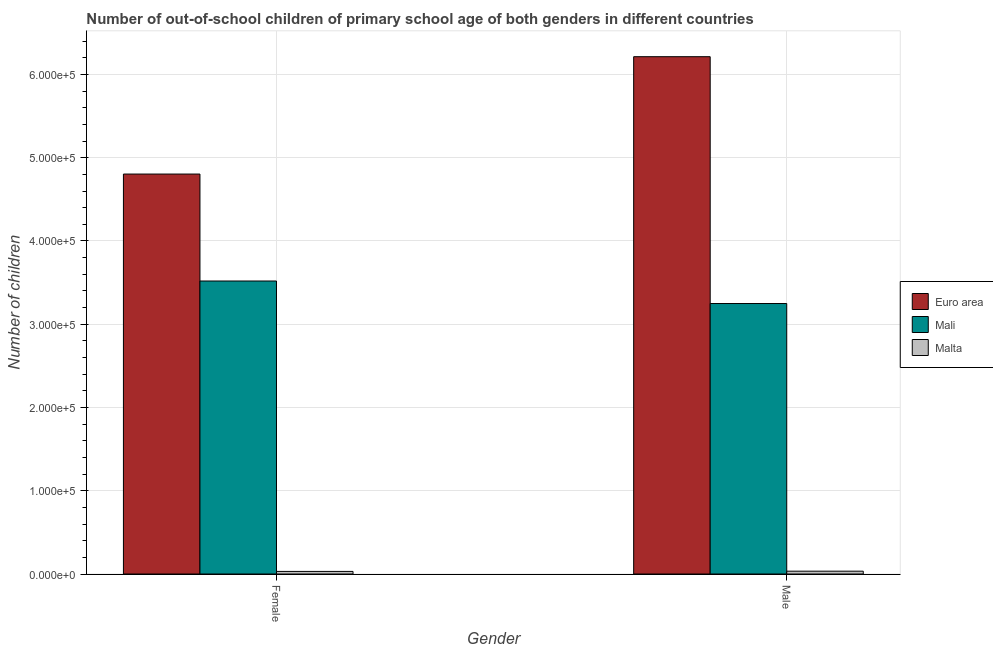Are the number of bars on each tick of the X-axis equal?
Provide a succinct answer. Yes. How many bars are there on the 1st tick from the right?
Provide a succinct answer. 3. What is the number of female out-of-school students in Malta?
Offer a terse response. 3105. Across all countries, what is the maximum number of female out-of-school students?
Make the answer very short. 4.80e+05. Across all countries, what is the minimum number of male out-of-school students?
Provide a succinct answer. 3394. In which country was the number of female out-of-school students maximum?
Offer a very short reply. Euro area. In which country was the number of female out-of-school students minimum?
Offer a terse response. Malta. What is the total number of female out-of-school students in the graph?
Ensure brevity in your answer.  8.35e+05. What is the difference between the number of male out-of-school students in Malta and that in Euro area?
Offer a terse response. -6.18e+05. What is the difference between the number of female out-of-school students in Mali and the number of male out-of-school students in Malta?
Your answer should be very brief. 3.49e+05. What is the average number of female out-of-school students per country?
Give a very brief answer. 2.78e+05. What is the difference between the number of male out-of-school students and number of female out-of-school students in Malta?
Provide a short and direct response. 289. What is the ratio of the number of female out-of-school students in Euro area to that in Malta?
Keep it short and to the point. 154.71. Is the number of male out-of-school students in Malta less than that in Mali?
Make the answer very short. Yes. What does the 1st bar from the left in Male represents?
Ensure brevity in your answer.  Euro area. What does the 1st bar from the right in Male represents?
Keep it short and to the point. Malta. How many bars are there?
Your answer should be compact. 6. Are all the bars in the graph horizontal?
Make the answer very short. No. How many countries are there in the graph?
Your answer should be very brief. 3. How many legend labels are there?
Provide a succinct answer. 3. How are the legend labels stacked?
Provide a succinct answer. Vertical. What is the title of the graph?
Your answer should be very brief. Number of out-of-school children of primary school age of both genders in different countries. What is the label or title of the Y-axis?
Offer a very short reply. Number of children. What is the Number of children of Euro area in Female?
Make the answer very short. 4.80e+05. What is the Number of children of Mali in Female?
Your answer should be compact. 3.52e+05. What is the Number of children in Malta in Female?
Provide a succinct answer. 3105. What is the Number of children in Euro area in Male?
Your answer should be very brief. 6.21e+05. What is the Number of children in Mali in Male?
Provide a short and direct response. 3.25e+05. What is the Number of children in Malta in Male?
Make the answer very short. 3394. Across all Gender, what is the maximum Number of children of Euro area?
Keep it short and to the point. 6.21e+05. Across all Gender, what is the maximum Number of children of Mali?
Your answer should be compact. 3.52e+05. Across all Gender, what is the maximum Number of children of Malta?
Offer a very short reply. 3394. Across all Gender, what is the minimum Number of children of Euro area?
Offer a terse response. 4.80e+05. Across all Gender, what is the minimum Number of children of Mali?
Provide a succinct answer. 3.25e+05. Across all Gender, what is the minimum Number of children of Malta?
Give a very brief answer. 3105. What is the total Number of children in Euro area in the graph?
Give a very brief answer. 1.10e+06. What is the total Number of children in Mali in the graph?
Provide a short and direct response. 6.77e+05. What is the total Number of children in Malta in the graph?
Ensure brevity in your answer.  6499. What is the difference between the Number of children in Euro area in Female and that in Male?
Your response must be concise. -1.41e+05. What is the difference between the Number of children in Mali in Female and that in Male?
Your answer should be very brief. 2.70e+04. What is the difference between the Number of children in Malta in Female and that in Male?
Provide a succinct answer. -289. What is the difference between the Number of children of Euro area in Female and the Number of children of Mali in Male?
Keep it short and to the point. 1.56e+05. What is the difference between the Number of children in Euro area in Female and the Number of children in Malta in Male?
Keep it short and to the point. 4.77e+05. What is the difference between the Number of children in Mali in Female and the Number of children in Malta in Male?
Keep it short and to the point. 3.49e+05. What is the average Number of children in Euro area per Gender?
Your answer should be compact. 5.51e+05. What is the average Number of children of Mali per Gender?
Provide a short and direct response. 3.38e+05. What is the average Number of children of Malta per Gender?
Your answer should be very brief. 3249.5. What is the difference between the Number of children in Euro area and Number of children in Mali in Female?
Offer a terse response. 1.28e+05. What is the difference between the Number of children of Euro area and Number of children of Malta in Female?
Make the answer very short. 4.77e+05. What is the difference between the Number of children in Mali and Number of children in Malta in Female?
Make the answer very short. 3.49e+05. What is the difference between the Number of children in Euro area and Number of children in Mali in Male?
Your answer should be very brief. 2.96e+05. What is the difference between the Number of children of Euro area and Number of children of Malta in Male?
Offer a very short reply. 6.18e+05. What is the difference between the Number of children of Mali and Number of children of Malta in Male?
Your answer should be very brief. 3.21e+05. What is the ratio of the Number of children of Euro area in Female to that in Male?
Make the answer very short. 0.77. What is the ratio of the Number of children in Mali in Female to that in Male?
Make the answer very short. 1.08. What is the ratio of the Number of children in Malta in Female to that in Male?
Make the answer very short. 0.91. What is the difference between the highest and the second highest Number of children of Euro area?
Offer a terse response. 1.41e+05. What is the difference between the highest and the second highest Number of children of Mali?
Your answer should be very brief. 2.70e+04. What is the difference between the highest and the second highest Number of children of Malta?
Provide a succinct answer. 289. What is the difference between the highest and the lowest Number of children in Euro area?
Your answer should be very brief. 1.41e+05. What is the difference between the highest and the lowest Number of children in Mali?
Make the answer very short. 2.70e+04. What is the difference between the highest and the lowest Number of children in Malta?
Offer a terse response. 289. 